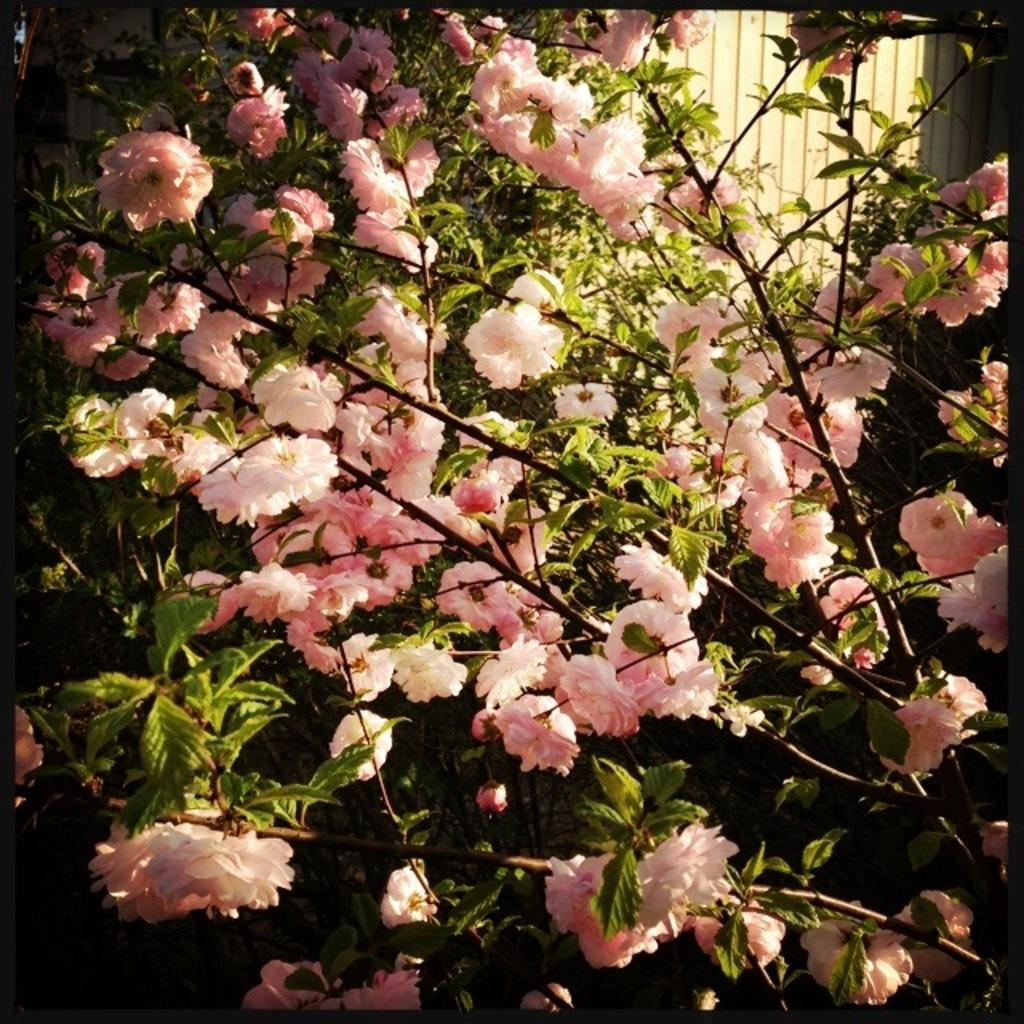What type of living organisms can be seen in the image? Plants can be seen in the image. What specific feature of the plants is noteworthy? Each plant has many flowers. Can you describe the wooden object in the image? There is a wooden object at the top right of the image. What type of birds can be seen flying near the plants in the image? There are no birds present in the image; it only features plants and a wooden object. Can you tell me how many volleyballs are visible in the image? There are no volleyballs present in the image. 